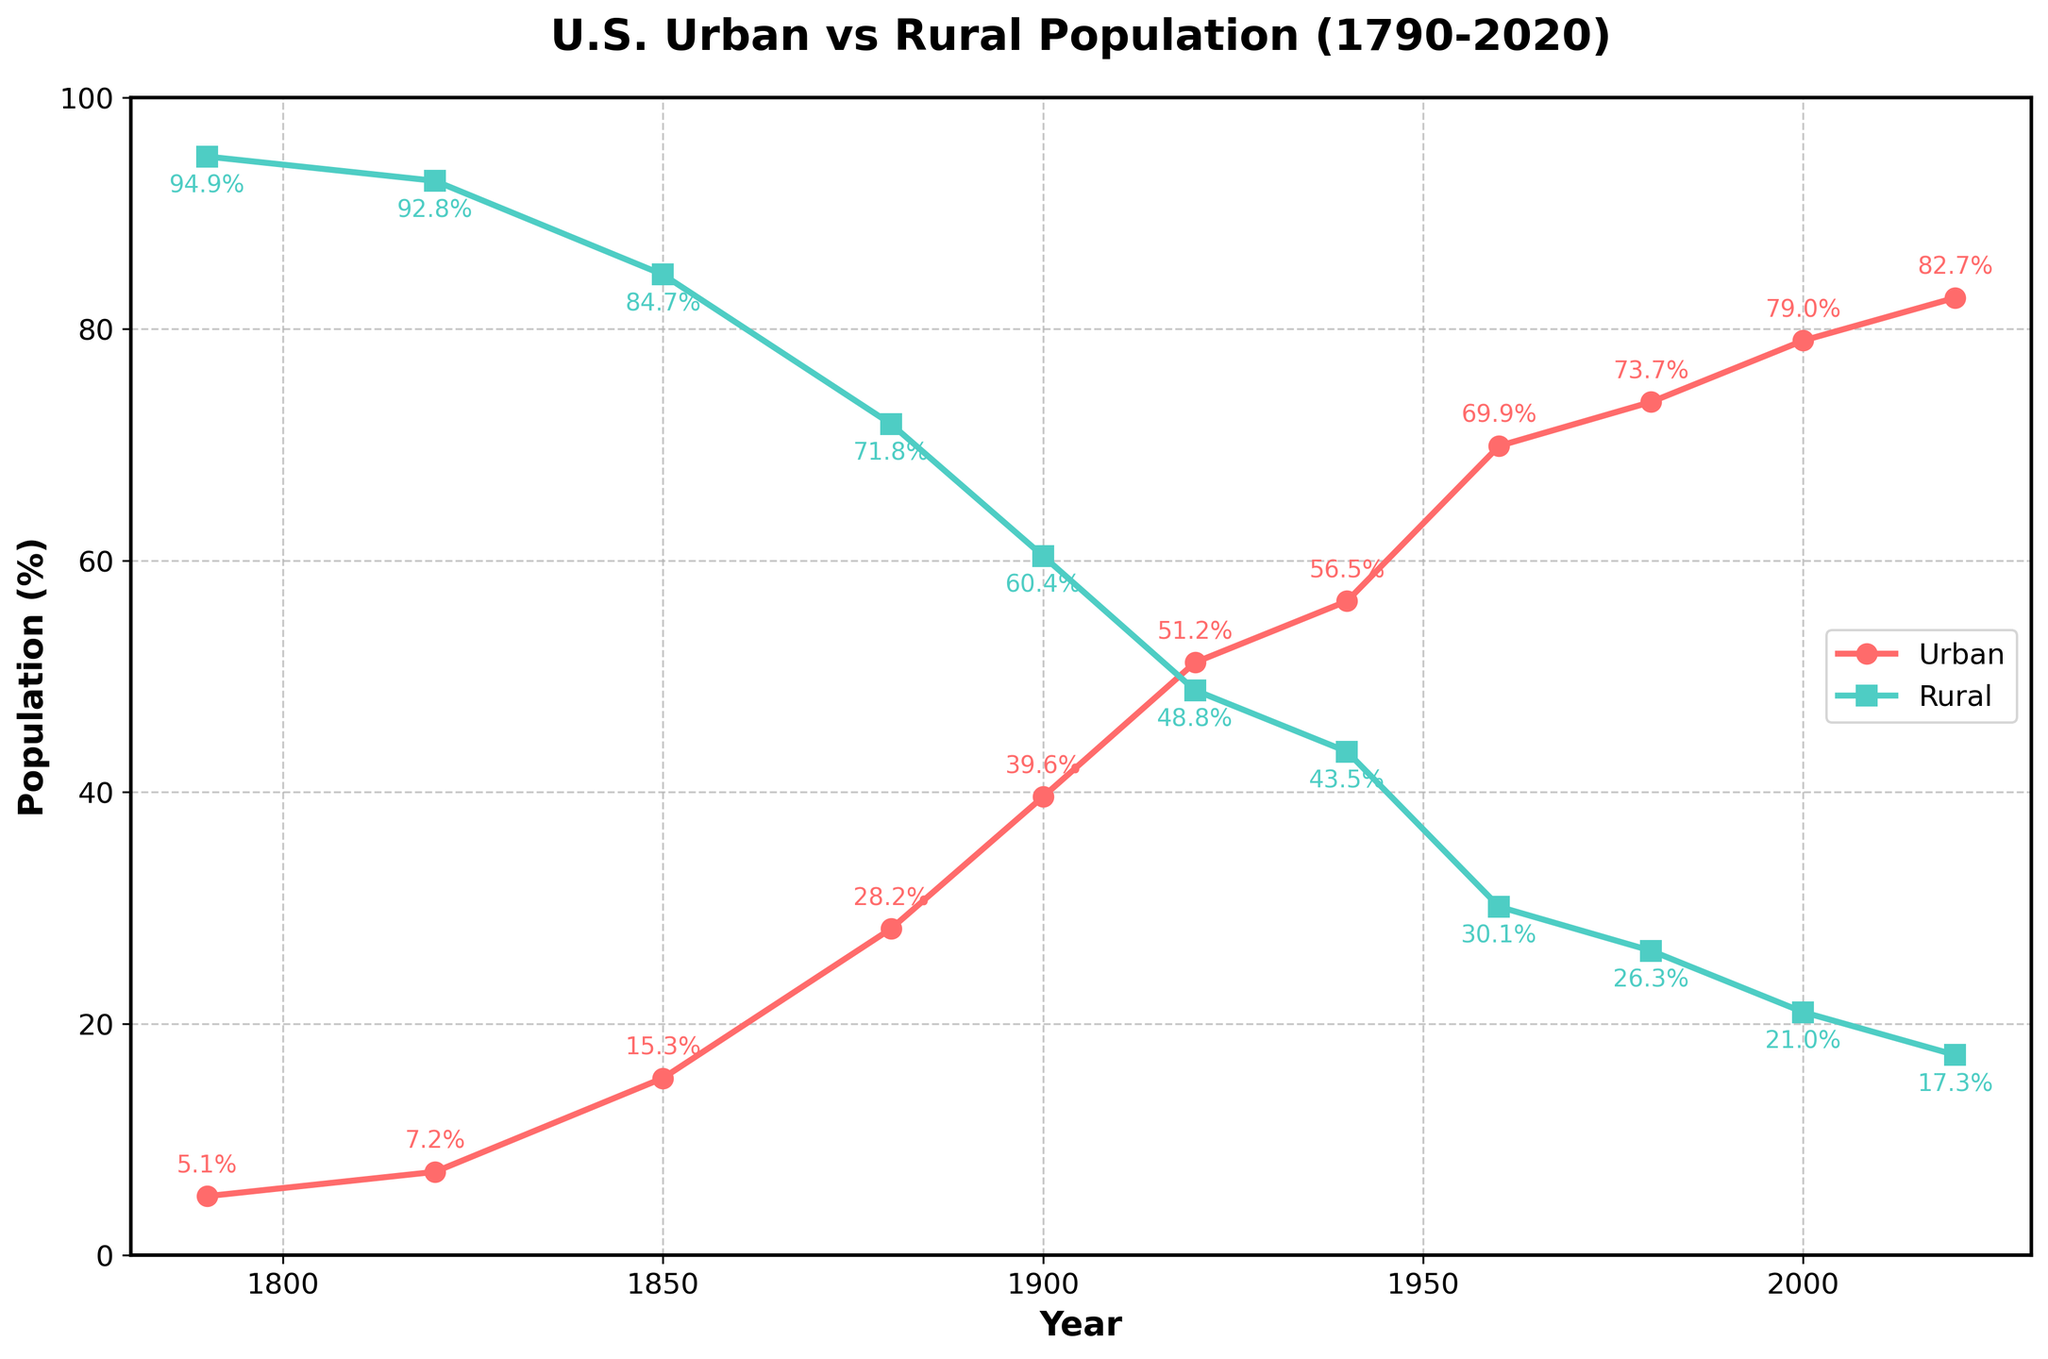What trend do we observe for the urban population between 1790 and 2020? The urban population percentage shows a steadily increasing trend from 5.1% in 1790 to 82.7% in 2020.
Answer: Steadily increasing In which year did the urban population percentage surpass the rural population percentage? By examining the crossing point of the two lines, we find that the urban population percentage went above 50% in 1920.
Answer: 1920 What is the difference in the rural population percentage between 1900 and 2000? In 1900, the rural population percentage was 60.4%, and in 2000, it was 21.0%. The difference is calculated as 60.4% - 21.0% = 39.4%.
Answer: 39.4% Which population percentage had a larger increase between 1790 and 2020, urban or rural? The urban population percentage increased from 5.1% to 82.7% (a change of 77.6%). The rural population percentage decreased from 94.9% to 17.3% (a change of 77.6%). Both show the same magnitude of change (77.6%).
Answer: Equal, 77.6% What can we infer about the trend of urban and rural populations after 1920? From 1920 onwards, the urban population percentage consistently increases while the rural population percentage decreases. The two lines diverge further apart from 1920 to 2020.
Answer: Urban increases, rural decreases How does the rate of change in the urban population from 1790 to 1920 compare with the rate from 1920 to 2020? From 1790 (5.1%) to 1920 (51.2%), the urban population increased by 51.2% - 5.1% = 46.1% over 130 years, averaging 46.1/130 ≈ 0.355%. From 1920 (51.2%) to 2020 (82.7%), the increase is 82.7% - 51.2% = 31.5% over 100 years, averaging 31.5/100 = 0.315%. The rate of change from 1790 to 1920 is slightly higher.
Answer: Higher from 1790 to 1920 Which population had a steeper increase or decrease from 1850 to 1880? From 1850 to 1880, the urban population percentage increased from 15.3% to 28.2% (an increase of 12.9%), while the rural population decreased from 84.7% to 71.8% (a decrease of 12.9%). Both had changes of equal magnitude.
Answer: Equal change of 12.9% What is the combined population percentage of urban and rural in 1940? In 1940, the urban population percentage is 56.5%, and the rural percentage is 43.5%. Adding them together, 56.5% + 43.5% = 100%.
Answer: 100% What is the median urban population percentage over the entire period (1790-2020)? The urban population percentages are: 5.1, 7.2, 15.3, 28.2, 39.6, 51.2, 56.5, 69.9, 73.7, 79.0, 82.7. Ordering these values, the median (middle value in an ordered list) is 51.2%.
Answer: 51.2% 